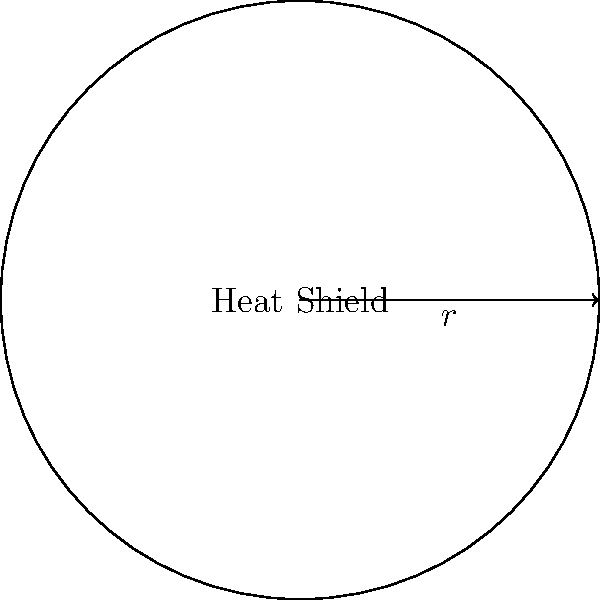As a spacecraft designer, you are tasked with calculating the area of a circular heat shield. If the radius of the heat shield is 5 meters, what is its total area in square meters? Round your answer to two decimal places. To calculate the area of a circular heat shield, we can use the formula for the area of a circle:

$$A = \pi r^2$$

Where:
$A$ = Area of the circle
$\pi$ = Pi (approximately 3.14159)
$r$ = Radius of the circle

Given:
$r = 5$ meters

Step 1: Substitute the given radius into the formula.
$$A = \pi (5)^2$$

Step 2: Calculate the square of the radius.
$$A = \pi (25)$$

Step 3: Multiply by π.
$$A = 25\pi \approx 78.53981634$$

Step 4: Round the result to two decimal places.
$$A \approx 78.54 \text{ m}^2$$

Therefore, the area of the circular heat shield is approximately 78.54 square meters.
Answer: $78.54 \text{ m}^2$ 